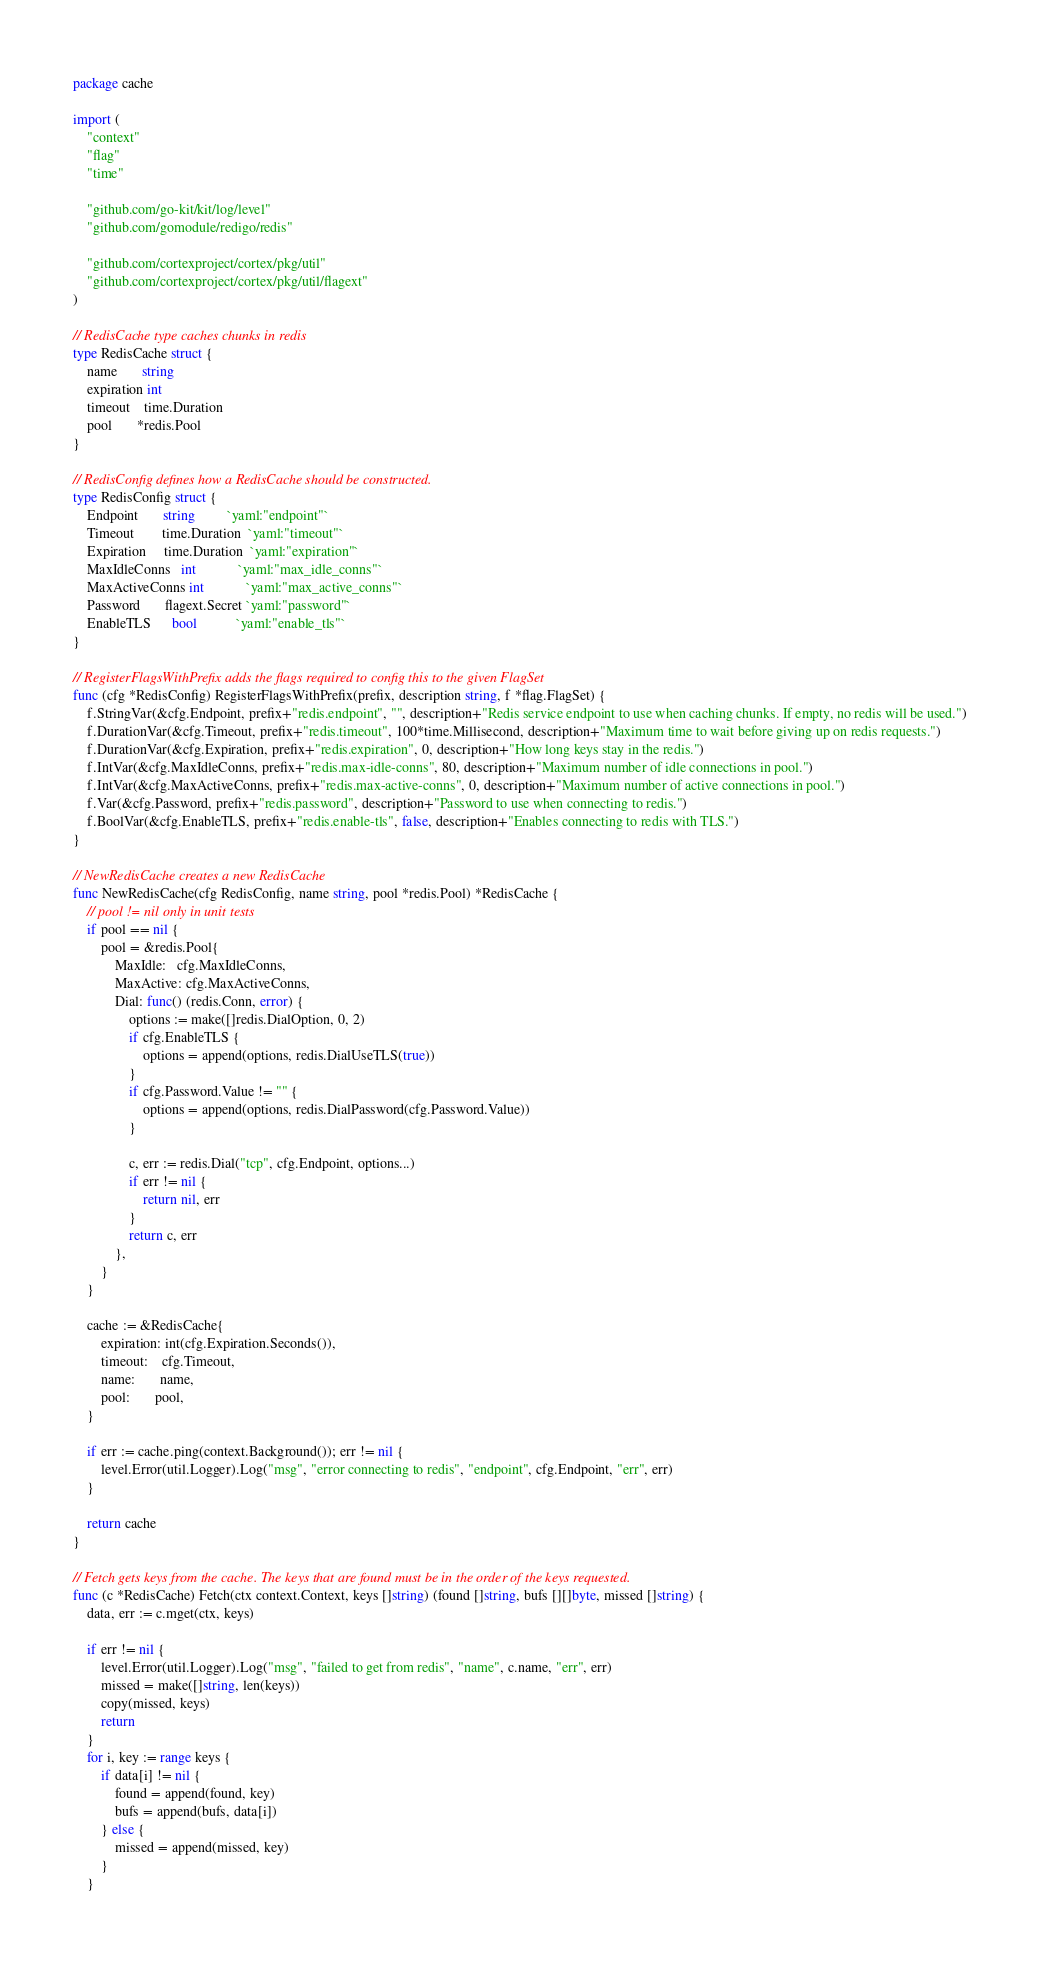Convert code to text. <code><loc_0><loc_0><loc_500><loc_500><_Go_>package cache

import (
	"context"
	"flag"
	"time"

	"github.com/go-kit/kit/log/level"
	"github.com/gomodule/redigo/redis"

	"github.com/cortexproject/cortex/pkg/util"
	"github.com/cortexproject/cortex/pkg/util/flagext"
)

// RedisCache type caches chunks in redis
type RedisCache struct {
	name       string
	expiration int
	timeout    time.Duration
	pool       *redis.Pool
}

// RedisConfig defines how a RedisCache should be constructed.
type RedisConfig struct {
	Endpoint       string         `yaml:"endpoint"`
	Timeout        time.Duration  `yaml:"timeout"`
	Expiration     time.Duration  `yaml:"expiration"`
	MaxIdleConns   int            `yaml:"max_idle_conns"`
	MaxActiveConns int            `yaml:"max_active_conns"`
	Password       flagext.Secret `yaml:"password"`
	EnableTLS      bool           `yaml:"enable_tls"`
}

// RegisterFlagsWithPrefix adds the flags required to config this to the given FlagSet
func (cfg *RedisConfig) RegisterFlagsWithPrefix(prefix, description string, f *flag.FlagSet) {
	f.StringVar(&cfg.Endpoint, prefix+"redis.endpoint", "", description+"Redis service endpoint to use when caching chunks. If empty, no redis will be used.")
	f.DurationVar(&cfg.Timeout, prefix+"redis.timeout", 100*time.Millisecond, description+"Maximum time to wait before giving up on redis requests.")
	f.DurationVar(&cfg.Expiration, prefix+"redis.expiration", 0, description+"How long keys stay in the redis.")
	f.IntVar(&cfg.MaxIdleConns, prefix+"redis.max-idle-conns", 80, description+"Maximum number of idle connections in pool.")
	f.IntVar(&cfg.MaxActiveConns, prefix+"redis.max-active-conns", 0, description+"Maximum number of active connections in pool.")
	f.Var(&cfg.Password, prefix+"redis.password", description+"Password to use when connecting to redis.")
	f.BoolVar(&cfg.EnableTLS, prefix+"redis.enable-tls", false, description+"Enables connecting to redis with TLS.")
}

// NewRedisCache creates a new RedisCache
func NewRedisCache(cfg RedisConfig, name string, pool *redis.Pool) *RedisCache {
	// pool != nil only in unit tests
	if pool == nil {
		pool = &redis.Pool{
			MaxIdle:   cfg.MaxIdleConns,
			MaxActive: cfg.MaxActiveConns,
			Dial: func() (redis.Conn, error) {
				options := make([]redis.DialOption, 0, 2)
				if cfg.EnableTLS {
					options = append(options, redis.DialUseTLS(true))
				}
				if cfg.Password.Value != "" {
					options = append(options, redis.DialPassword(cfg.Password.Value))
				}

				c, err := redis.Dial("tcp", cfg.Endpoint, options...)
				if err != nil {
					return nil, err
				}
				return c, err
			},
		}
	}

	cache := &RedisCache{
		expiration: int(cfg.Expiration.Seconds()),
		timeout:    cfg.Timeout,
		name:       name,
		pool:       pool,
	}

	if err := cache.ping(context.Background()); err != nil {
		level.Error(util.Logger).Log("msg", "error connecting to redis", "endpoint", cfg.Endpoint, "err", err)
	}

	return cache
}

// Fetch gets keys from the cache. The keys that are found must be in the order of the keys requested.
func (c *RedisCache) Fetch(ctx context.Context, keys []string) (found []string, bufs [][]byte, missed []string) {
	data, err := c.mget(ctx, keys)

	if err != nil {
		level.Error(util.Logger).Log("msg", "failed to get from redis", "name", c.name, "err", err)
		missed = make([]string, len(keys))
		copy(missed, keys)
		return
	}
	for i, key := range keys {
		if data[i] != nil {
			found = append(found, key)
			bufs = append(bufs, data[i])
		} else {
			missed = append(missed, key)
		}
	}</code> 